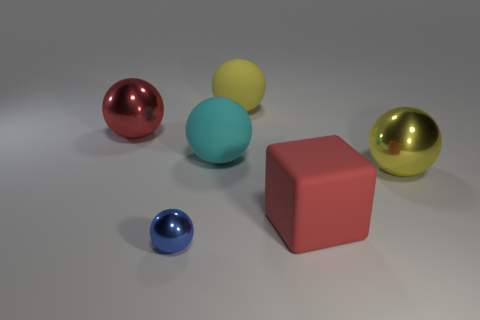What does the arrangement of objects suggest to you? The arrangement of the objects does not appear to adhere to any recognizable pattern or structure. It seems more like a casual placement for aesthetic or display purposes. The varied colors and shapes may suggest a study in geometry and color theory, or simply serve as a visual composition for artistic or illustrative use. 